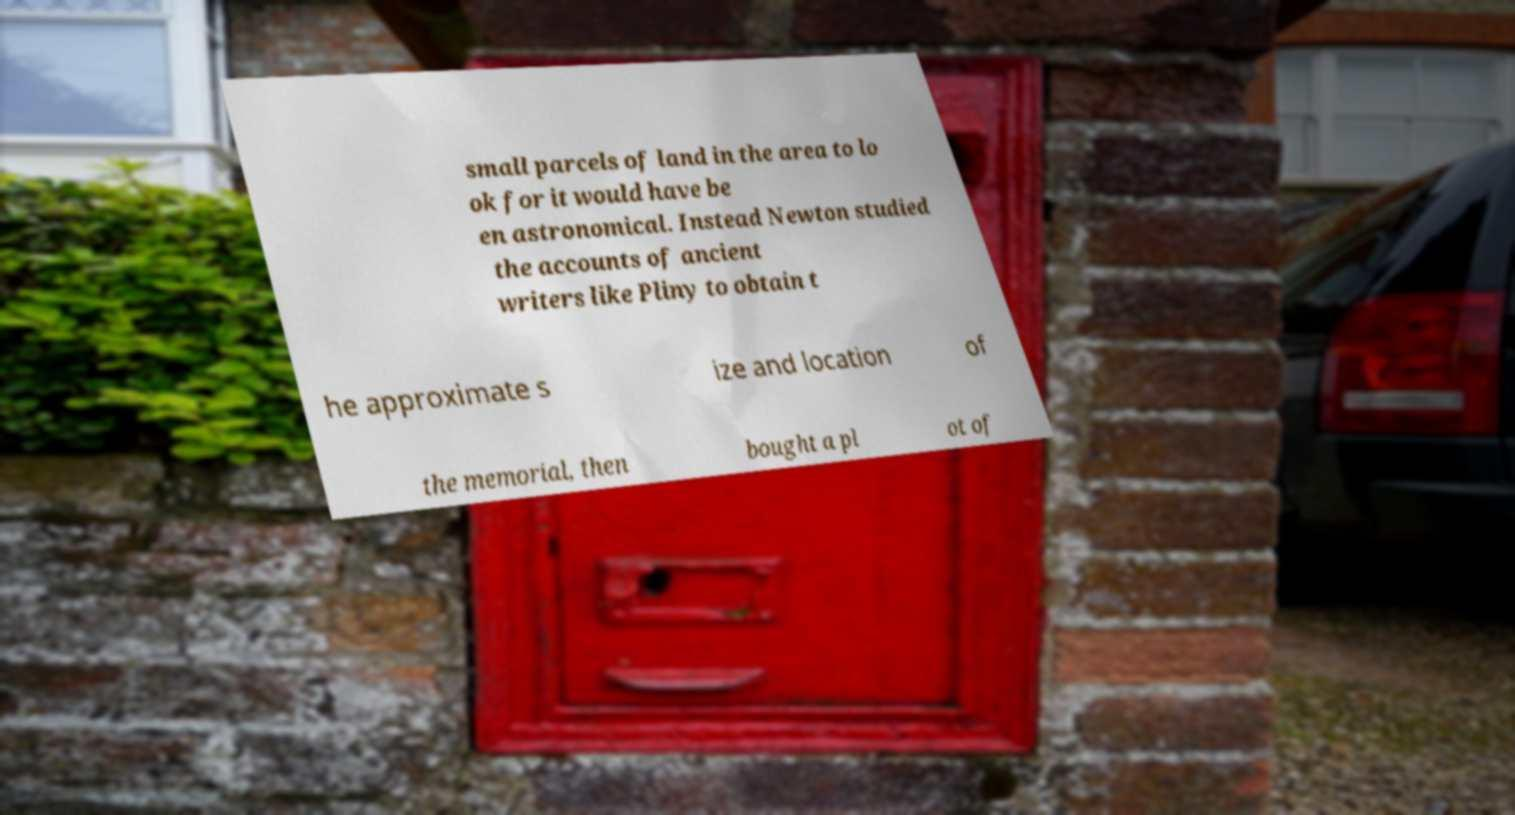Could you extract and type out the text from this image? small parcels of land in the area to lo ok for it would have be en astronomical. Instead Newton studied the accounts of ancient writers like Pliny to obtain t he approximate s ize and location of the memorial, then bought a pl ot of 